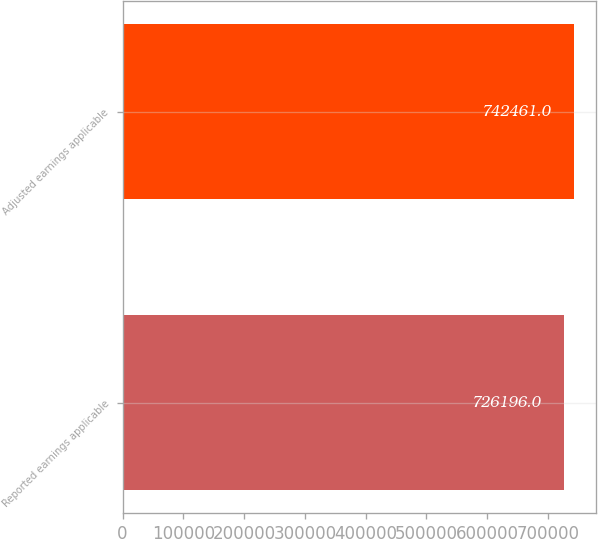Convert chart. <chart><loc_0><loc_0><loc_500><loc_500><bar_chart><fcel>Reported earnings applicable<fcel>Adjusted earnings applicable<nl><fcel>726196<fcel>742461<nl></chart> 